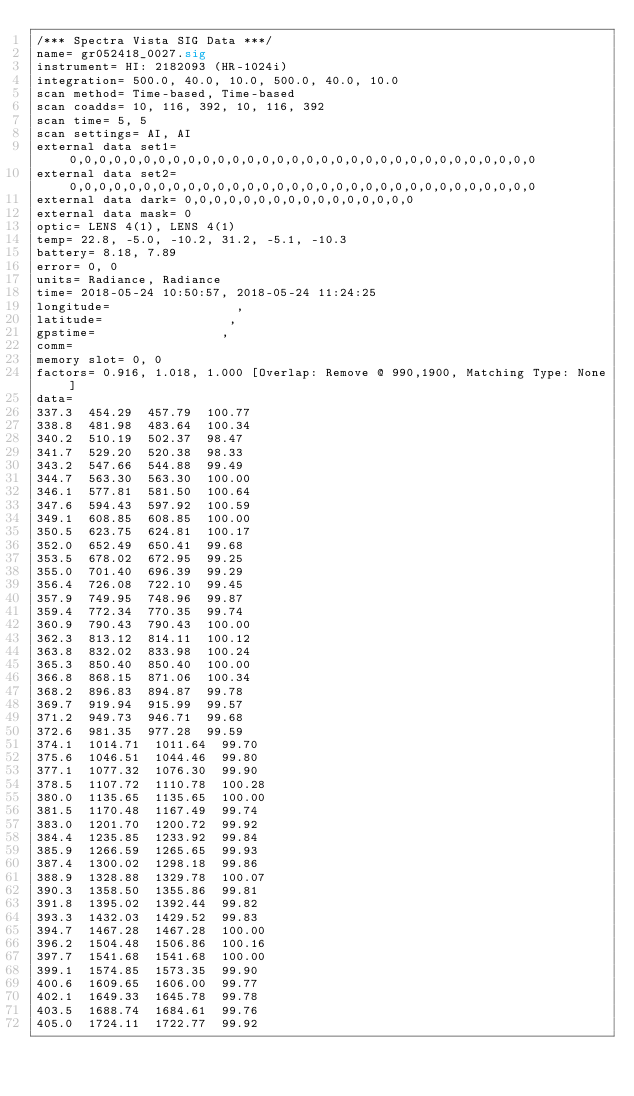<code> <loc_0><loc_0><loc_500><loc_500><_SML_>/*** Spectra Vista SIG Data ***/
name= gr052418_0027.sig
instrument= HI: 2182093 (HR-1024i)
integration= 500.0, 40.0, 10.0, 500.0, 40.0, 10.0
scan method= Time-based, Time-based
scan coadds= 10, 116, 392, 10, 116, 392
scan time= 5, 5
scan settings= AI, AI
external data set1= 0,0,0,0,0,0,0,0,0,0,0,0,0,0,0,0,0,0,0,0,0,0,0,0,0,0,0,0,0,0,0,0
external data set2= 0,0,0,0,0,0,0,0,0,0,0,0,0,0,0,0,0,0,0,0,0,0,0,0,0,0,0,0,0,0,0,0
external data dark= 0,0,0,0,0,0,0,0,0,0,0,0,0,0,0,0
external data mask= 0
optic= LENS 4(1), LENS 4(1)
temp= 22.8, -5.0, -10.2, 31.2, -5.1, -10.3
battery= 8.18, 7.89
error= 0, 0
units= Radiance, Radiance
time= 2018-05-24 10:50:57, 2018-05-24 11:24:25
longitude=                 ,                 
latitude=                 ,                 
gpstime=                 ,                 
comm= 
memory slot= 0, 0
factors= 0.916, 1.018, 1.000 [Overlap: Remove @ 990,1900, Matching Type: None]
data= 
337.3  454.29  457.79  100.77
338.8  481.98  483.64  100.34
340.2  510.19  502.37  98.47
341.7  529.20  520.38  98.33
343.2  547.66  544.88  99.49
344.7  563.30  563.30  100.00
346.1  577.81  581.50  100.64
347.6  594.43  597.92  100.59
349.1  608.85  608.85  100.00
350.5  623.75  624.81  100.17
352.0  652.49  650.41  99.68
353.5  678.02  672.95  99.25
355.0  701.40  696.39  99.29
356.4  726.08  722.10  99.45
357.9  749.95  748.96  99.87
359.4  772.34  770.35  99.74
360.9  790.43  790.43  100.00
362.3  813.12  814.11  100.12
363.8  832.02  833.98  100.24
365.3  850.40  850.40  100.00
366.8  868.15  871.06  100.34
368.2  896.83  894.87  99.78
369.7  919.94  915.99  99.57
371.2  949.73  946.71  99.68
372.6  981.35  977.28  99.59
374.1  1014.71  1011.64  99.70
375.6  1046.51  1044.46  99.80
377.1  1077.32  1076.30  99.90
378.5  1107.72  1110.78  100.28
380.0  1135.65  1135.65  100.00
381.5  1170.48  1167.49  99.74
383.0  1201.70  1200.72  99.92
384.4  1235.85  1233.92  99.84
385.9  1266.59  1265.65  99.93
387.4  1300.02  1298.18  99.86
388.9  1328.88  1329.78  100.07
390.3  1358.50  1355.86  99.81
391.8  1395.02  1392.44  99.82
393.3  1432.03  1429.52  99.83
394.7  1467.28  1467.28  100.00
396.2  1504.48  1506.86  100.16
397.7  1541.68  1541.68  100.00
399.1  1574.85  1573.35  99.90
400.6  1609.65  1606.00  99.77
402.1  1649.33  1645.78  99.78
403.5  1688.74  1684.61  99.76
405.0  1724.11  1722.77  99.92</code> 